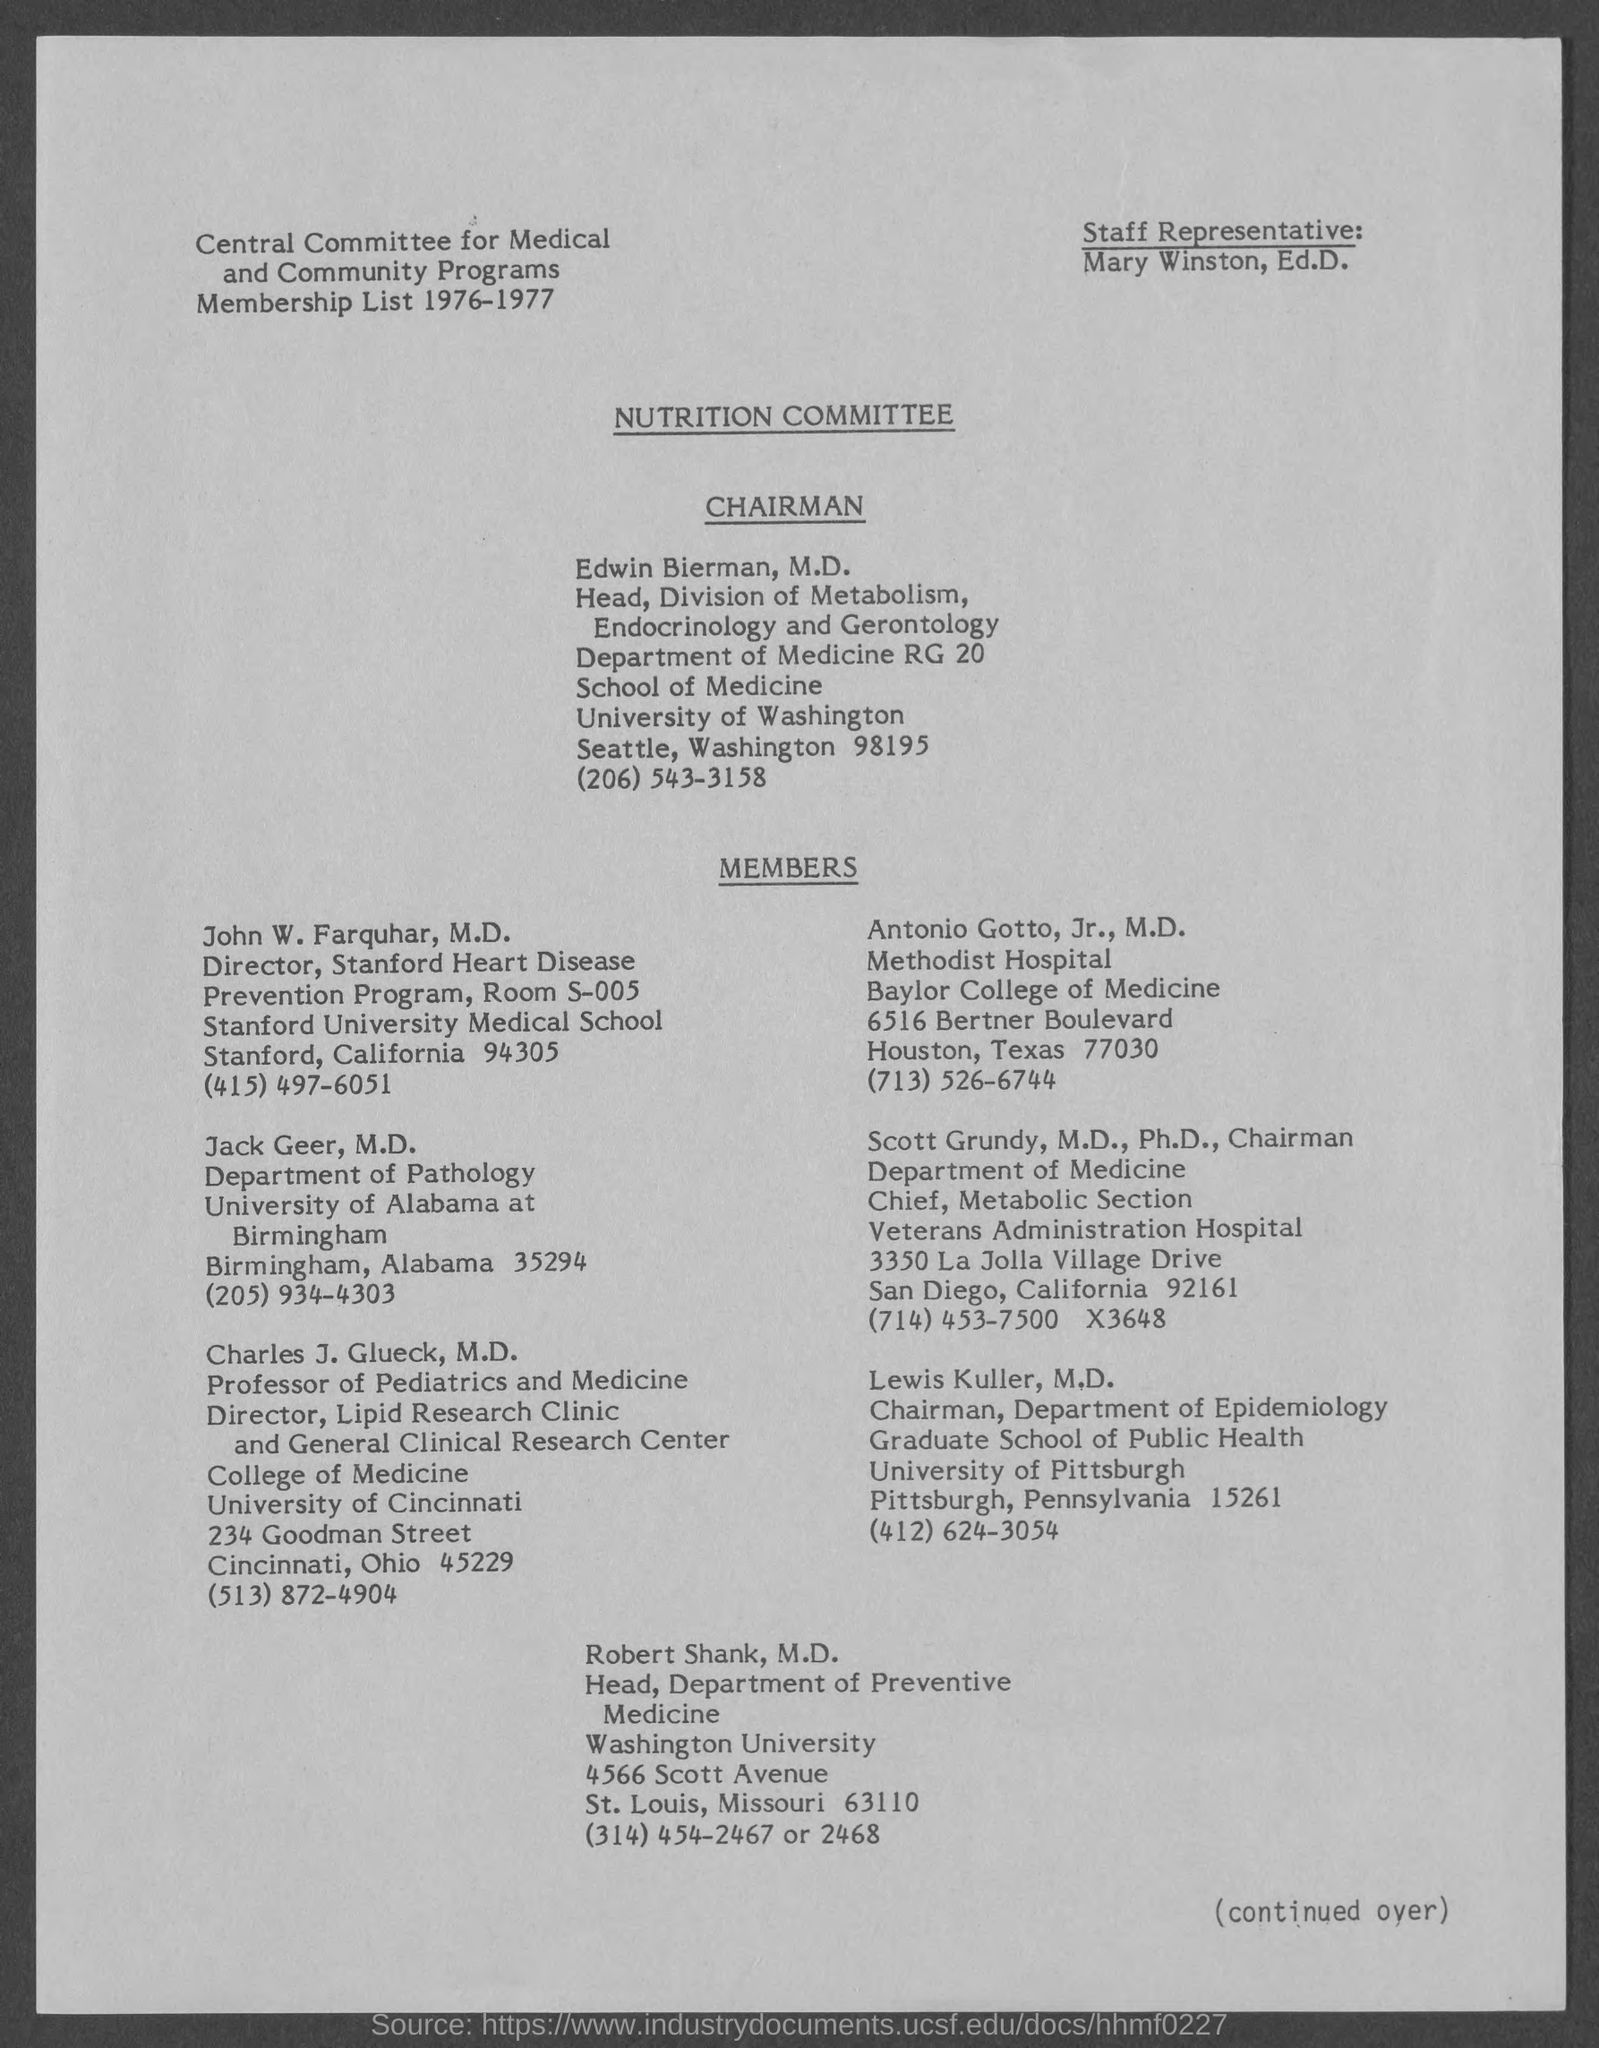Outline some significant characteristics in this image. Jack Geer is a member of the Department of Pathology. Lewis Kuller is affiliated with the University of Pittsburgh. The Staff Representative is Mary Winston. The membership list is from the year 1976-1977. Edwin Bierman, M.D., is the chairman of the NUTRITION COMMITTEE. 